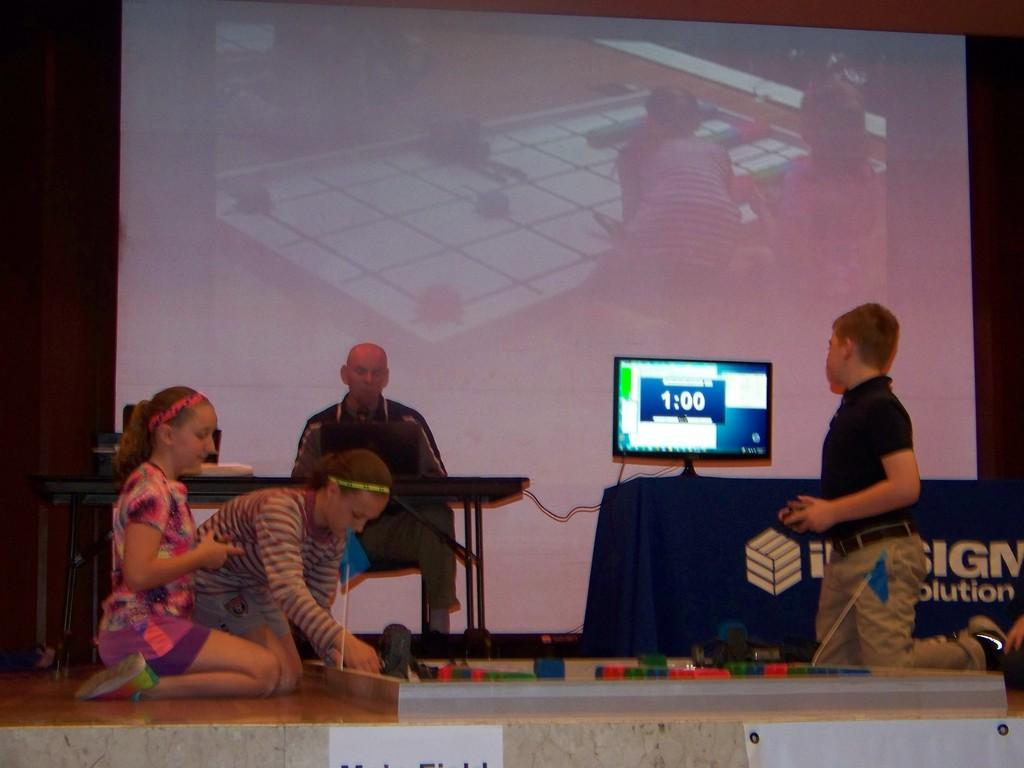How many people are on the stage in the image? There are four persons on the stage. What can be seen in the background of the image? There is a screen and a wall in the background. What is present on a table in the background? There is a monitor on a table in the background. What can be inferred about the location of the image? The image is likely taken on a stage. What is the purpose of the ear in the image? There is no ear present in the image. What design elements can be seen on the wall in the image? The provided facts do not mention any specific design elements on the wall. 